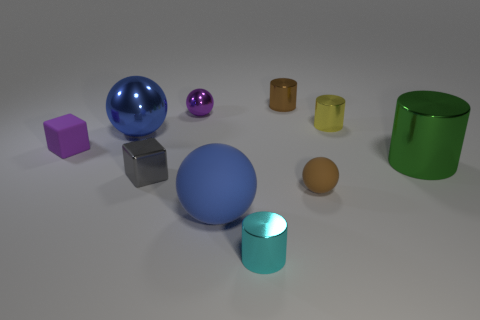Subtract all cylinders. How many objects are left? 6 Subtract 0 blue blocks. How many objects are left? 10 Subtract all purple things. Subtract all small purple objects. How many objects are left? 6 Add 4 cyan things. How many cyan things are left? 5 Add 6 big matte balls. How many big matte balls exist? 7 